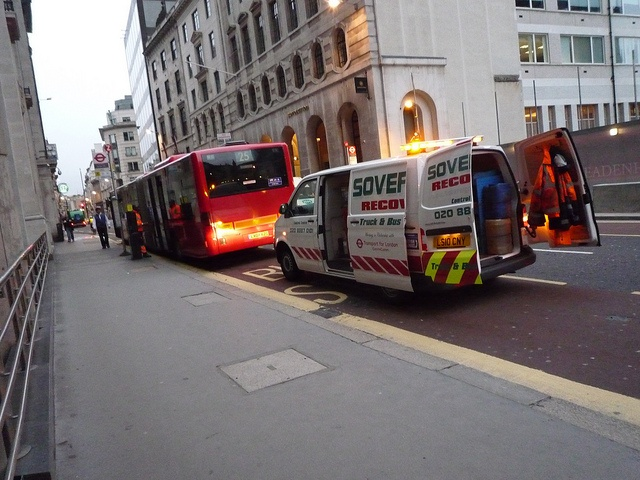Describe the objects in this image and their specific colors. I can see truck in gray, black, maroon, and darkgray tones, bus in gray, black, brown, and maroon tones, people in gray, black, maroon, brown, and olive tones, people in gray, black, and darkgray tones, and truck in gray, black, teal, and maroon tones in this image. 